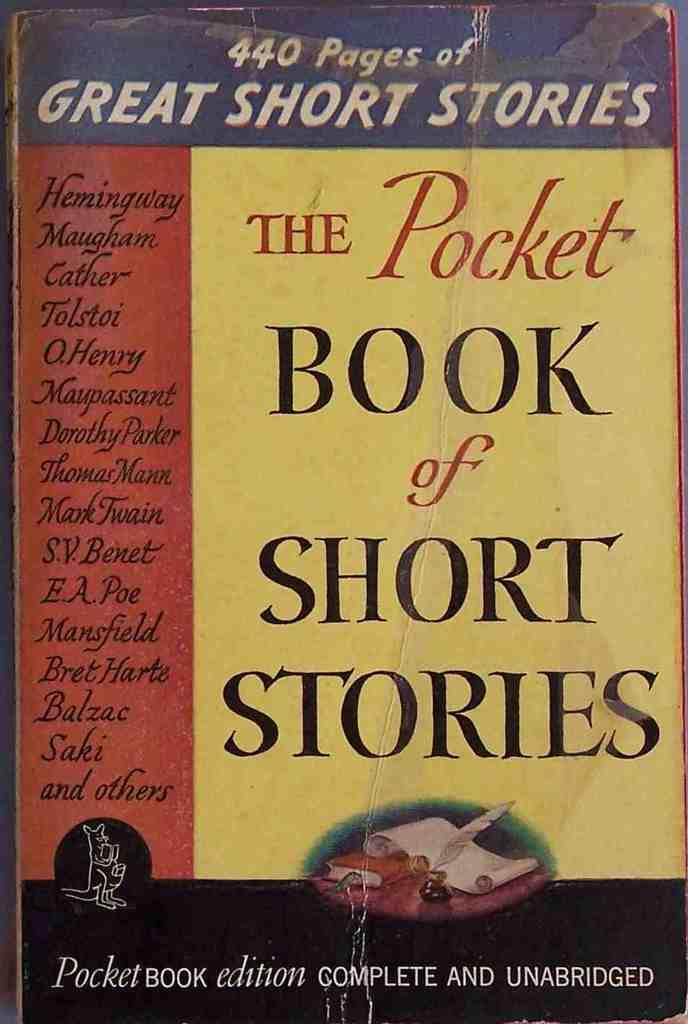What is located in the foreground of the image? There is a book in the foreground of the image. What can be found on the book? There is text on the book. What type of rabbit can be seen sneezing in the box in the image? There is no rabbit or box present in the image; it only features a book with text. 